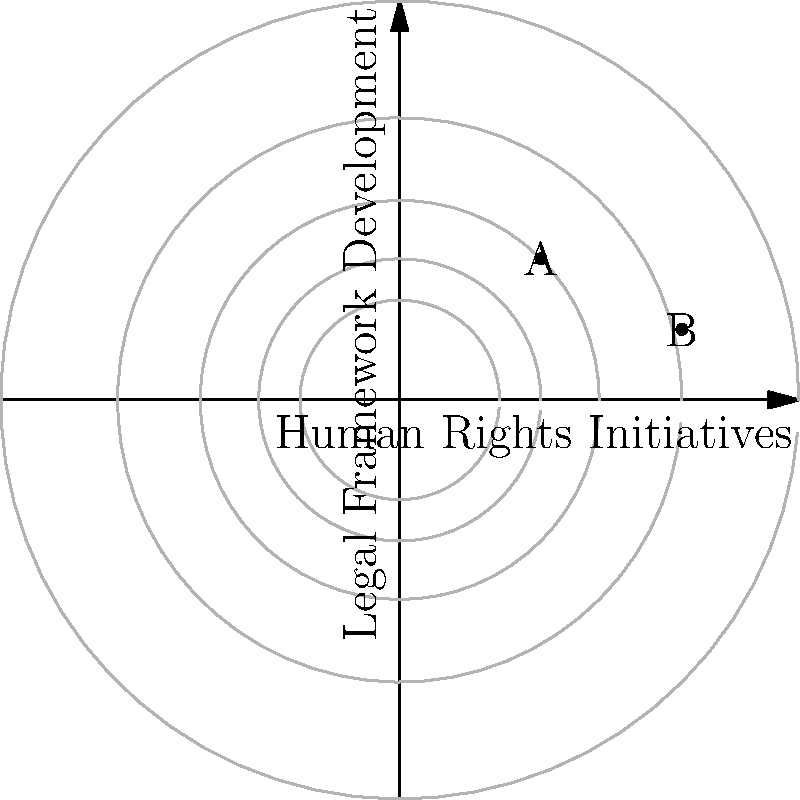In the context of Afghan affairs, a political analyst is optimizing resource allocation between human rights initiatives (x-axis) and legal framework development (y-axis). The contour lines represent the total impact of these efforts, with higher values indicating greater impact. Given that point A (1, 1) and point B (2, 0.5) are two possible allocation strategies, which point represents the optimal resource allocation for maximizing impact? Justify your answer using the principles of optimization. To determine the optimal resource allocation, we need to analyze the contour lines and apply the principles of optimization:

1. Contour lines: Each contour line represents combinations of x and y that yield the same total impact. The further a contour line is from the origin, the higher the impact.

2. Gradient: The direction of steepest increase is perpendicular to the contour lines.

3. Optimization principle: The optimal point occurs where the constraint (in this case, our resource limit) is tangent to the highest possible contour line.

4. Comparing points:
   - Point A (1, 1) is on a contour line closer to the origin than Point B (2, 0.5).
   - Point B is on a contour line further from the origin.

5. Interpretation:
   - Point B being on a higher contour line indicates that it yields a greater total impact.
   - This suggests that allocating more resources to human rights initiatives (x-axis) and slightly fewer to legal framework development (y-axis) results in a higher overall impact.

6. Policy implication: In the context of Afghan affairs, this result suggests that while both areas are important, focusing slightly more on human rights initiatives may lead to a greater overall positive impact on the country's development.

Therefore, Point B (2, 0.5) represents the optimal resource allocation for maximizing impact in this scenario.
Answer: Point B (2, 0.5) 